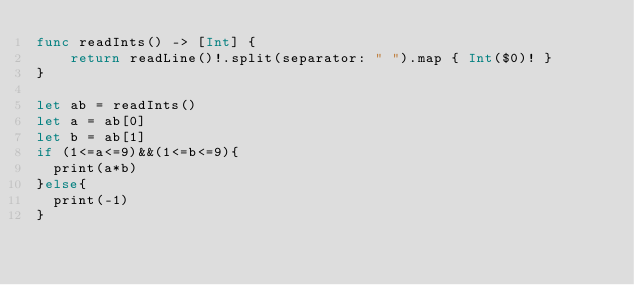<code> <loc_0><loc_0><loc_500><loc_500><_Swift_>func readInts() -> [Int] {
    return readLine()!.split(separator: " ").map { Int($0)! }
}
    
let ab = readInts()
let a = ab[0]
let b = ab[1]
if (1<=a<=9)&&(1<=b<=9){
  print(a*b)
}else{
  print(-1)
} 
</code> 